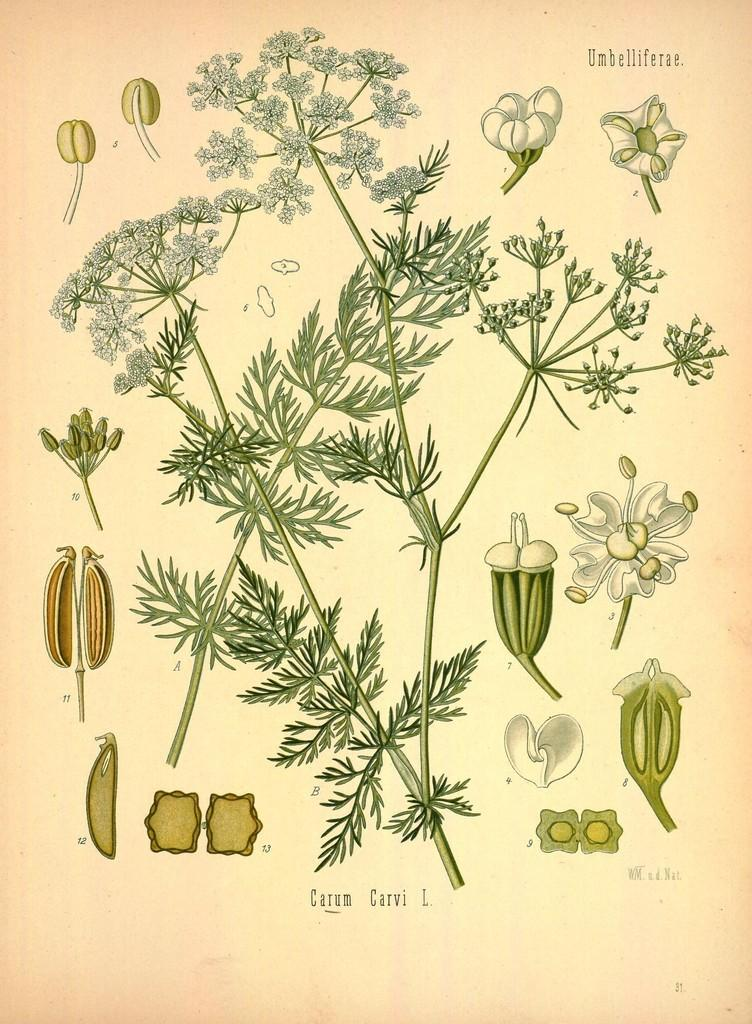What is featured on the poster in the image? There is a poster in the image that depicts a plant. Can you describe the plant on the poster? The plant on the poster has leaves and flowers. Are there any other elements on the poster besides the plant? Yes, there are other items depicted on the poster. How does the plant use its brake to stop moving in the image? Plants do not have brakes, as they are stationary organisms. The plant in the image is not moving, and therefore, there is no need for a brake. 